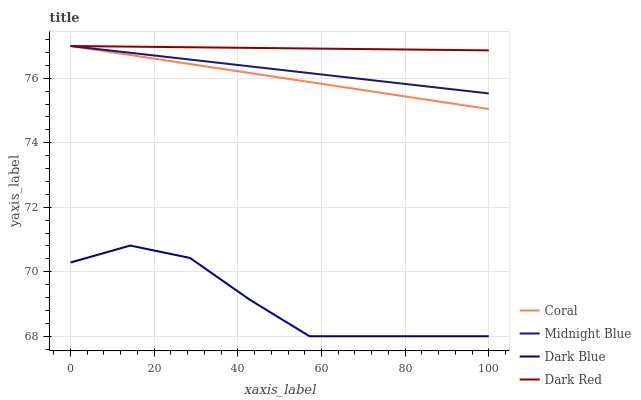Does Dark Blue have the minimum area under the curve?
Answer yes or no. Yes. Does Dark Red have the maximum area under the curve?
Answer yes or no. Yes. Does Coral have the minimum area under the curve?
Answer yes or no. No. Does Coral have the maximum area under the curve?
Answer yes or no. No. Is Dark Red the smoothest?
Answer yes or no. Yes. Is Dark Blue the roughest?
Answer yes or no. Yes. Is Coral the smoothest?
Answer yes or no. No. Is Coral the roughest?
Answer yes or no. No. Does Dark Blue have the lowest value?
Answer yes or no. Yes. Does Coral have the lowest value?
Answer yes or no. No. Does Dark Red have the highest value?
Answer yes or no. Yes. Is Dark Blue less than Coral?
Answer yes or no. Yes. Is Midnight Blue greater than Dark Blue?
Answer yes or no. Yes. Does Coral intersect Midnight Blue?
Answer yes or no. Yes. Is Coral less than Midnight Blue?
Answer yes or no. No. Is Coral greater than Midnight Blue?
Answer yes or no. No. Does Dark Blue intersect Coral?
Answer yes or no. No. 